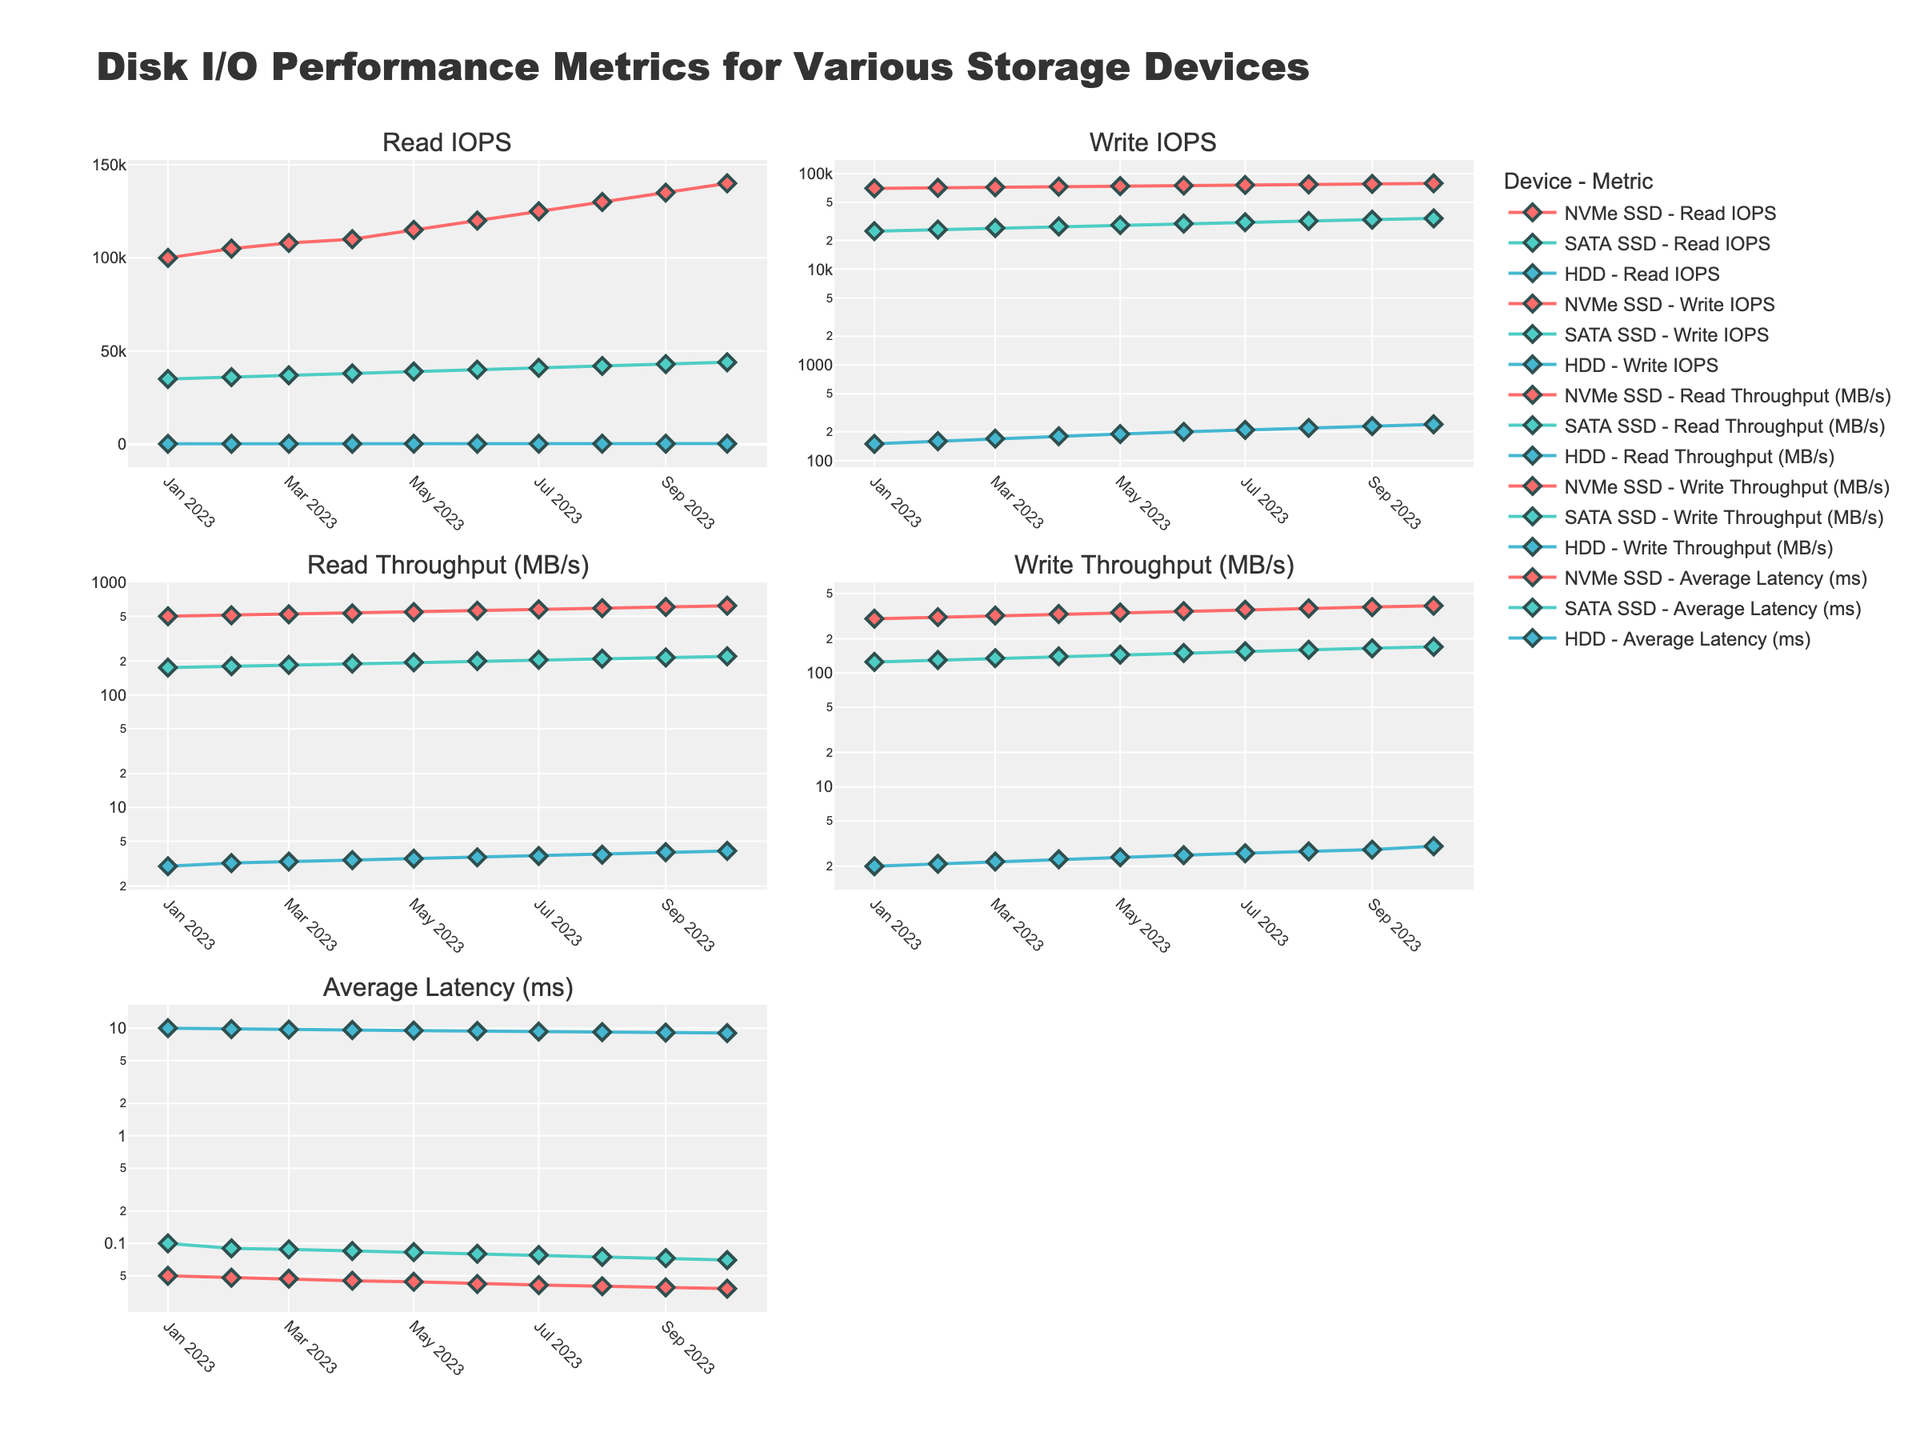What is the title of the figure? The title of the figure is displayed at the top and provides a brief description of the plot's content.
Answer: "Disk I/O Performance Metrics for Various Storage Devices" Which metric has the lowest values for HDD in January 2023? To find the lowest value, refer to the "HDD" data points in January 2023 for all metrics (Read IOPS, Write IOPS, Read Throughput, Write Throughput, Average Latency). The lowest value here would be Write Throughput (2 MB/s).
Answer: Write Throughput (2 MB/s) How do the Read IOPS for NVMe SSDs change from January to October 2023? Look at the subplot titled "Read IOPS" and observe the trend line of the NVMe SSD from January to October 2023. The Read IOPS for NVMe SSDs start at 100,000 in January and increase to 140,000 by October.
Answer: Increase to 140,000 Which storage device shows the greatest improvement in Average Latency from January to October 2023? Compare the "Average Latency (ms)" subplot for each device between January and October. The NVMe SSD shows the greatest improvement, reducing latency from 0.05 ms to 0.038 ms.
Answer: NVMe SSD Which month sees SATA SSDs' Write Throughput cross 150 MB/s? In the subplot for Write Throughput (MB/s), observe when the line for "SATA SSD" crosses the 150 MB/s mark. It crosses 150 MB/s in May 2023.
Answer: May 2023 Compare the trend for HDD Read IOPS and NVMe SSD Read IOPS over the months. In the "Read IOPS" subplot, observe both HDD and NVMe SSD lines. NVMe SSD shows a steep increase from 100,000 to 140,000, while HDD has a slight increase from 200 to 290.
Answer: NVMe SSD shows a steep increase; HDD a slight increase By what percentage did the Write IOPS for the SATA SSD increase from January to October 2023? Calculate the percentage increase from the data points in January (25,000 Write IOPS) and October (34,000 Write IOPS). The increase is ((34,000 - 25,000) / 25,000) * 100%.
Answer: 36% What is the difference between NVMe SSD's Read Throughput and Write Throughput in October 2023? From the October data in the "Read Throughput" and "Write Throughput" subplots, subtract Write Throughput (390 MB/s) from Read Throughput (620 MB/s). The difference is 230 MB/s.
Answer: 230 MB/s Which storage device consistently had the highest average latency throughout 2023? From the "Average Latency (ms)" subplot, observe which device consistently records the highest latency. HDD consistently shows the highest average latency.
Answer: HDD Identify one instance where the performance of any metric decreased for a storage device from one month to the next. Examine each subplot for any decline in metric values from one month to the next. In the "Average Latency (ms)" subplot, the latency for HDD decreases from 10 ms in January to 9.8 ms in February.
Answer: HDD's latency decreased from January to February 